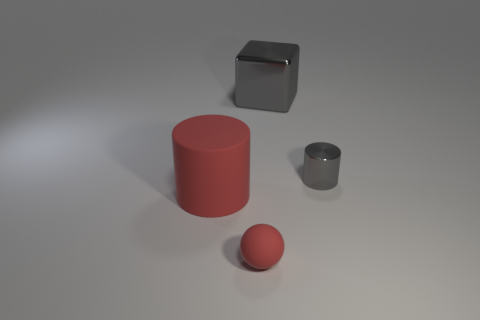Subtract 0 purple cylinders. How many objects are left? 4 Subtract all balls. How many objects are left? 3 Subtract 1 balls. How many balls are left? 0 Subtract all brown spheres. Subtract all blue cylinders. How many spheres are left? 1 Subtract all red blocks. How many blue cylinders are left? 0 Subtract all large cylinders. Subtract all large things. How many objects are left? 1 Add 4 small gray metallic cylinders. How many small gray metallic cylinders are left? 5 Add 3 large things. How many large things exist? 5 Add 1 large gray metal blocks. How many objects exist? 5 Subtract all gray cylinders. How many cylinders are left? 1 